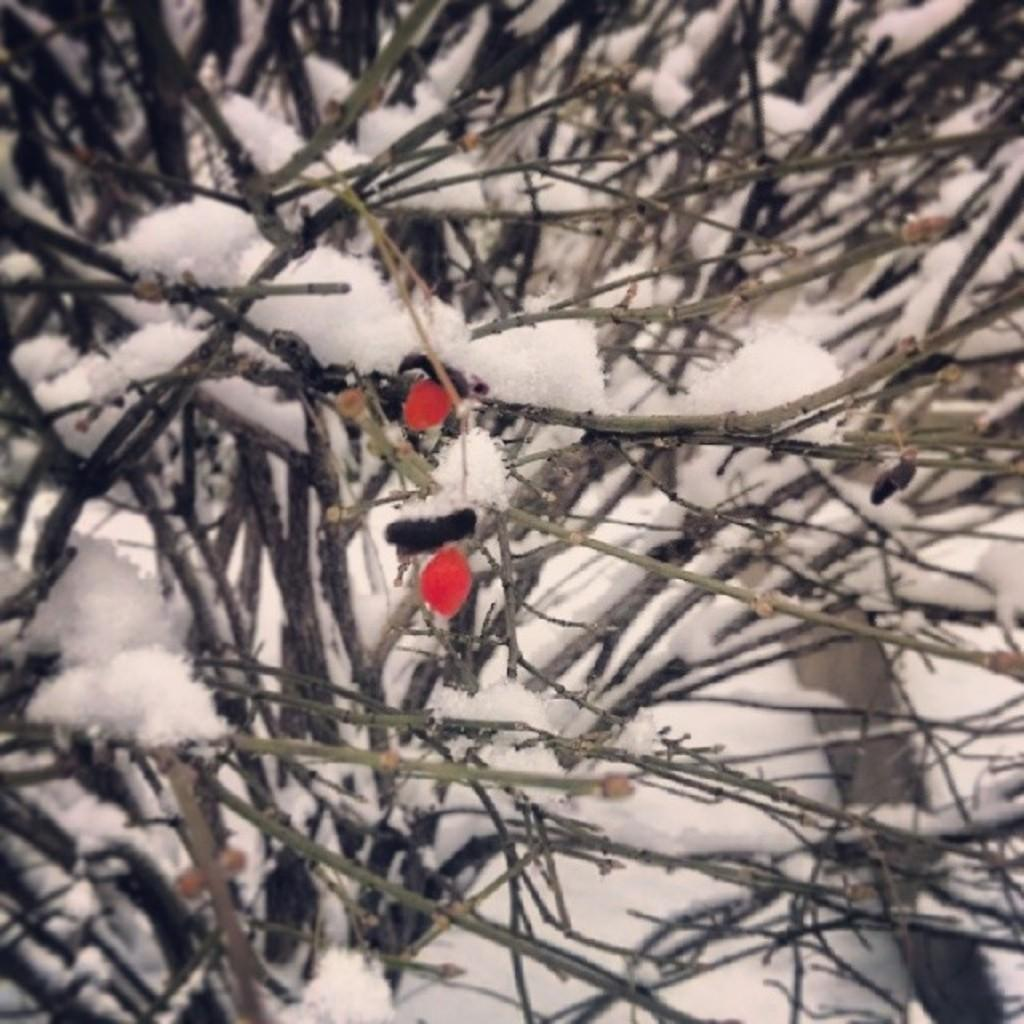What type of living organisms can be seen in the image? Plants can be seen in the image. What is covering the plants in the image? The plants have snow on them. What color is the background of the image? The background of the image is white. What type of floor can be seen in the image? There is no floor visible in the image; it only shows plants with snow on them against a white background. 